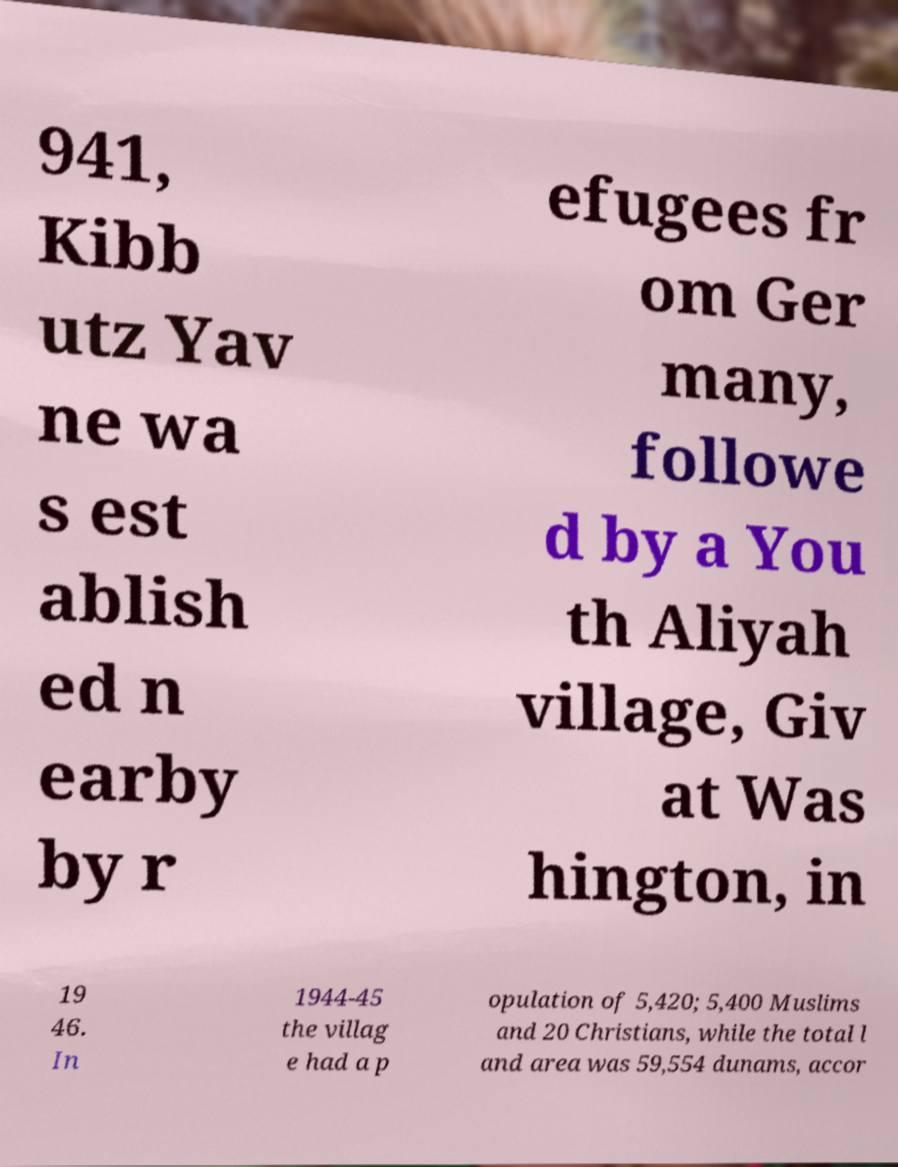For documentation purposes, I need the text within this image transcribed. Could you provide that? 941, Kibb utz Yav ne wa s est ablish ed n earby by r efugees fr om Ger many, followe d by a You th Aliyah village, Giv at Was hington, in 19 46. In 1944-45 the villag e had a p opulation of 5,420; 5,400 Muslims and 20 Christians, while the total l and area was 59,554 dunams, accor 